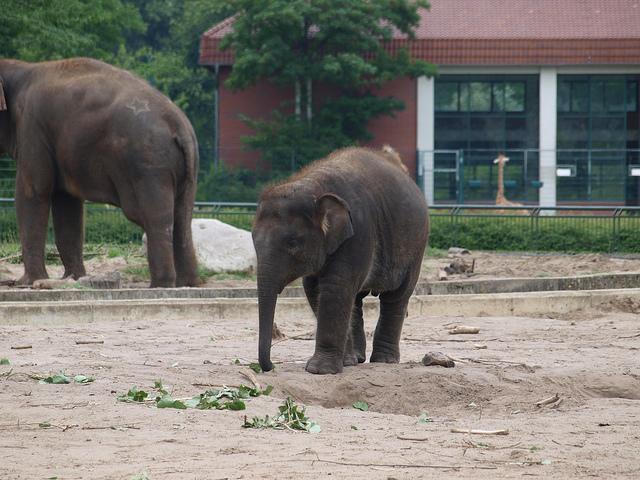Does the elephant have tusks?
Keep it brief. No. How many different sizes of elephants are visible?
Be succinct. 2. Are any elephants in the water?
Quick response, please. No. Where is the baby elephants?
Give a very brief answer. Dirt. Is this animal fully grown?
Write a very short answer. No. Are the elephants casting a shadow?
Answer briefly. No. Are they taking the little elephant home?
Keep it brief. No. Which animal is this?
Be succinct. Elephant. 